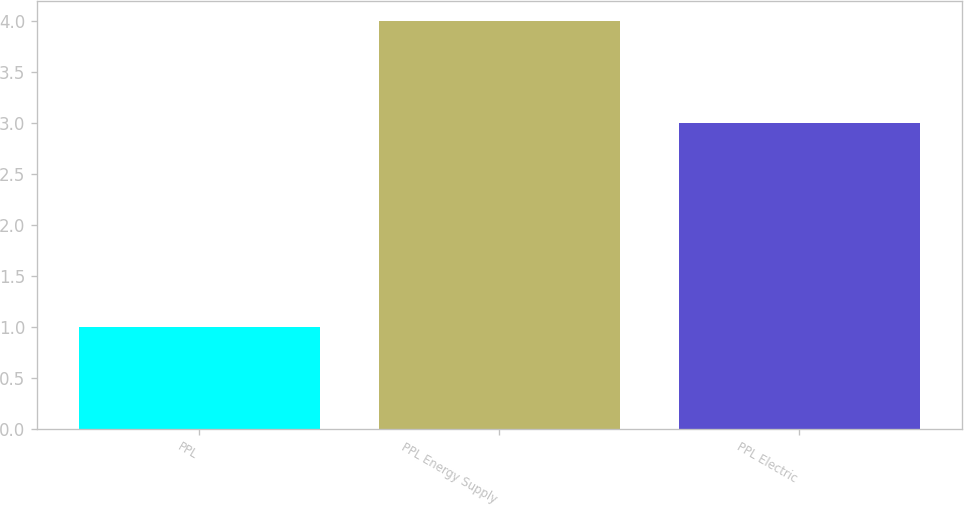Convert chart. <chart><loc_0><loc_0><loc_500><loc_500><bar_chart><fcel>PPL<fcel>PPL Energy Supply<fcel>PPL Electric<nl><fcel>1<fcel>4<fcel>3<nl></chart> 